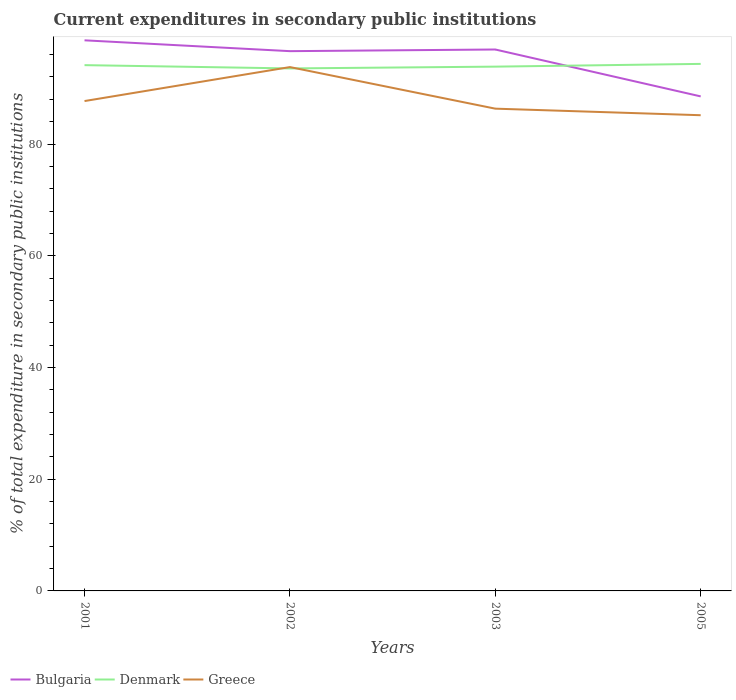How many different coloured lines are there?
Make the answer very short. 3. Is the number of lines equal to the number of legend labels?
Offer a very short reply. Yes. Across all years, what is the maximum current expenditures in secondary public institutions in Greece?
Give a very brief answer. 85.16. In which year was the current expenditures in secondary public institutions in Greece maximum?
Make the answer very short. 2005. What is the total current expenditures in secondary public institutions in Denmark in the graph?
Keep it short and to the point. -0.22. What is the difference between the highest and the second highest current expenditures in secondary public institutions in Greece?
Offer a very short reply. 8.62. How many years are there in the graph?
Keep it short and to the point. 4. What is the difference between two consecutive major ticks on the Y-axis?
Give a very brief answer. 20. What is the title of the graph?
Give a very brief answer. Current expenditures in secondary public institutions. Does "Micronesia" appear as one of the legend labels in the graph?
Your answer should be very brief. No. What is the label or title of the X-axis?
Ensure brevity in your answer.  Years. What is the label or title of the Y-axis?
Provide a short and direct response. % of total expenditure in secondary public institutions. What is the % of total expenditure in secondary public institutions of Bulgaria in 2001?
Provide a succinct answer. 98.57. What is the % of total expenditure in secondary public institutions of Denmark in 2001?
Give a very brief answer. 94.12. What is the % of total expenditure in secondary public institutions in Greece in 2001?
Your answer should be compact. 87.69. What is the % of total expenditure in secondary public institutions in Bulgaria in 2002?
Ensure brevity in your answer.  96.63. What is the % of total expenditure in secondary public institutions in Denmark in 2002?
Give a very brief answer. 93.53. What is the % of total expenditure in secondary public institutions of Greece in 2002?
Keep it short and to the point. 93.77. What is the % of total expenditure in secondary public institutions in Bulgaria in 2003?
Provide a succinct answer. 96.92. What is the % of total expenditure in secondary public institutions in Denmark in 2003?
Your response must be concise. 93.85. What is the % of total expenditure in secondary public institutions in Greece in 2003?
Ensure brevity in your answer.  86.33. What is the % of total expenditure in secondary public institutions of Bulgaria in 2005?
Make the answer very short. 88.53. What is the % of total expenditure in secondary public institutions of Denmark in 2005?
Ensure brevity in your answer.  94.35. What is the % of total expenditure in secondary public institutions in Greece in 2005?
Ensure brevity in your answer.  85.16. Across all years, what is the maximum % of total expenditure in secondary public institutions in Bulgaria?
Offer a very short reply. 98.57. Across all years, what is the maximum % of total expenditure in secondary public institutions in Denmark?
Keep it short and to the point. 94.35. Across all years, what is the maximum % of total expenditure in secondary public institutions in Greece?
Your answer should be compact. 93.77. Across all years, what is the minimum % of total expenditure in secondary public institutions of Bulgaria?
Ensure brevity in your answer.  88.53. Across all years, what is the minimum % of total expenditure in secondary public institutions of Denmark?
Your answer should be compact. 93.53. Across all years, what is the minimum % of total expenditure in secondary public institutions of Greece?
Your response must be concise. 85.16. What is the total % of total expenditure in secondary public institutions of Bulgaria in the graph?
Offer a terse response. 380.64. What is the total % of total expenditure in secondary public institutions of Denmark in the graph?
Your response must be concise. 375.86. What is the total % of total expenditure in secondary public institutions of Greece in the graph?
Your response must be concise. 352.96. What is the difference between the % of total expenditure in secondary public institutions in Bulgaria in 2001 and that in 2002?
Make the answer very short. 1.94. What is the difference between the % of total expenditure in secondary public institutions of Denmark in 2001 and that in 2002?
Give a very brief answer. 0.59. What is the difference between the % of total expenditure in secondary public institutions of Greece in 2001 and that in 2002?
Provide a short and direct response. -6.08. What is the difference between the % of total expenditure in secondary public institutions in Bulgaria in 2001 and that in 2003?
Ensure brevity in your answer.  1.64. What is the difference between the % of total expenditure in secondary public institutions in Denmark in 2001 and that in 2003?
Give a very brief answer. 0.27. What is the difference between the % of total expenditure in secondary public institutions of Greece in 2001 and that in 2003?
Your answer should be compact. 1.36. What is the difference between the % of total expenditure in secondary public institutions of Bulgaria in 2001 and that in 2005?
Your answer should be very brief. 10.04. What is the difference between the % of total expenditure in secondary public institutions of Denmark in 2001 and that in 2005?
Your answer should be very brief. -0.22. What is the difference between the % of total expenditure in secondary public institutions in Greece in 2001 and that in 2005?
Ensure brevity in your answer.  2.54. What is the difference between the % of total expenditure in secondary public institutions in Bulgaria in 2002 and that in 2003?
Your answer should be compact. -0.3. What is the difference between the % of total expenditure in secondary public institutions of Denmark in 2002 and that in 2003?
Your answer should be compact. -0.32. What is the difference between the % of total expenditure in secondary public institutions of Greece in 2002 and that in 2003?
Your answer should be compact. 7.44. What is the difference between the % of total expenditure in secondary public institutions in Bulgaria in 2002 and that in 2005?
Make the answer very short. 8.1. What is the difference between the % of total expenditure in secondary public institutions in Denmark in 2002 and that in 2005?
Provide a succinct answer. -0.81. What is the difference between the % of total expenditure in secondary public institutions of Greece in 2002 and that in 2005?
Provide a succinct answer. 8.62. What is the difference between the % of total expenditure in secondary public institutions in Bulgaria in 2003 and that in 2005?
Provide a succinct answer. 8.39. What is the difference between the % of total expenditure in secondary public institutions in Denmark in 2003 and that in 2005?
Your answer should be very brief. -0.49. What is the difference between the % of total expenditure in secondary public institutions of Greece in 2003 and that in 2005?
Ensure brevity in your answer.  1.18. What is the difference between the % of total expenditure in secondary public institutions of Bulgaria in 2001 and the % of total expenditure in secondary public institutions of Denmark in 2002?
Give a very brief answer. 5.03. What is the difference between the % of total expenditure in secondary public institutions in Bulgaria in 2001 and the % of total expenditure in secondary public institutions in Greece in 2002?
Give a very brief answer. 4.79. What is the difference between the % of total expenditure in secondary public institutions in Denmark in 2001 and the % of total expenditure in secondary public institutions in Greece in 2002?
Offer a very short reply. 0.35. What is the difference between the % of total expenditure in secondary public institutions in Bulgaria in 2001 and the % of total expenditure in secondary public institutions in Denmark in 2003?
Provide a short and direct response. 4.71. What is the difference between the % of total expenditure in secondary public institutions in Bulgaria in 2001 and the % of total expenditure in secondary public institutions in Greece in 2003?
Offer a very short reply. 12.23. What is the difference between the % of total expenditure in secondary public institutions in Denmark in 2001 and the % of total expenditure in secondary public institutions in Greece in 2003?
Provide a succinct answer. 7.79. What is the difference between the % of total expenditure in secondary public institutions in Bulgaria in 2001 and the % of total expenditure in secondary public institutions in Denmark in 2005?
Keep it short and to the point. 4.22. What is the difference between the % of total expenditure in secondary public institutions in Bulgaria in 2001 and the % of total expenditure in secondary public institutions in Greece in 2005?
Keep it short and to the point. 13.41. What is the difference between the % of total expenditure in secondary public institutions of Denmark in 2001 and the % of total expenditure in secondary public institutions of Greece in 2005?
Your answer should be compact. 8.97. What is the difference between the % of total expenditure in secondary public institutions in Bulgaria in 2002 and the % of total expenditure in secondary public institutions in Denmark in 2003?
Your answer should be very brief. 2.77. What is the difference between the % of total expenditure in secondary public institutions in Bulgaria in 2002 and the % of total expenditure in secondary public institutions in Greece in 2003?
Offer a terse response. 10.29. What is the difference between the % of total expenditure in secondary public institutions of Denmark in 2002 and the % of total expenditure in secondary public institutions of Greece in 2003?
Your response must be concise. 7.2. What is the difference between the % of total expenditure in secondary public institutions in Bulgaria in 2002 and the % of total expenditure in secondary public institutions in Denmark in 2005?
Provide a succinct answer. 2.28. What is the difference between the % of total expenditure in secondary public institutions in Bulgaria in 2002 and the % of total expenditure in secondary public institutions in Greece in 2005?
Give a very brief answer. 11.47. What is the difference between the % of total expenditure in secondary public institutions in Denmark in 2002 and the % of total expenditure in secondary public institutions in Greece in 2005?
Your answer should be compact. 8.38. What is the difference between the % of total expenditure in secondary public institutions in Bulgaria in 2003 and the % of total expenditure in secondary public institutions in Denmark in 2005?
Provide a short and direct response. 2.57. What is the difference between the % of total expenditure in secondary public institutions in Bulgaria in 2003 and the % of total expenditure in secondary public institutions in Greece in 2005?
Provide a succinct answer. 11.76. What is the difference between the % of total expenditure in secondary public institutions of Denmark in 2003 and the % of total expenditure in secondary public institutions of Greece in 2005?
Your answer should be compact. 8.7. What is the average % of total expenditure in secondary public institutions in Bulgaria per year?
Your answer should be compact. 95.16. What is the average % of total expenditure in secondary public institutions in Denmark per year?
Your response must be concise. 93.96. What is the average % of total expenditure in secondary public institutions in Greece per year?
Your answer should be very brief. 88.24. In the year 2001, what is the difference between the % of total expenditure in secondary public institutions of Bulgaria and % of total expenditure in secondary public institutions of Denmark?
Offer a terse response. 4.44. In the year 2001, what is the difference between the % of total expenditure in secondary public institutions in Bulgaria and % of total expenditure in secondary public institutions in Greece?
Your answer should be compact. 10.87. In the year 2001, what is the difference between the % of total expenditure in secondary public institutions in Denmark and % of total expenditure in secondary public institutions in Greece?
Your response must be concise. 6.43. In the year 2002, what is the difference between the % of total expenditure in secondary public institutions in Bulgaria and % of total expenditure in secondary public institutions in Denmark?
Offer a very short reply. 3.09. In the year 2002, what is the difference between the % of total expenditure in secondary public institutions of Bulgaria and % of total expenditure in secondary public institutions of Greece?
Keep it short and to the point. 2.85. In the year 2002, what is the difference between the % of total expenditure in secondary public institutions in Denmark and % of total expenditure in secondary public institutions in Greece?
Your answer should be compact. -0.24. In the year 2003, what is the difference between the % of total expenditure in secondary public institutions of Bulgaria and % of total expenditure in secondary public institutions of Denmark?
Keep it short and to the point. 3.07. In the year 2003, what is the difference between the % of total expenditure in secondary public institutions of Bulgaria and % of total expenditure in secondary public institutions of Greece?
Offer a terse response. 10.59. In the year 2003, what is the difference between the % of total expenditure in secondary public institutions of Denmark and % of total expenditure in secondary public institutions of Greece?
Ensure brevity in your answer.  7.52. In the year 2005, what is the difference between the % of total expenditure in secondary public institutions of Bulgaria and % of total expenditure in secondary public institutions of Denmark?
Make the answer very short. -5.82. In the year 2005, what is the difference between the % of total expenditure in secondary public institutions of Bulgaria and % of total expenditure in secondary public institutions of Greece?
Your answer should be compact. 3.37. In the year 2005, what is the difference between the % of total expenditure in secondary public institutions in Denmark and % of total expenditure in secondary public institutions in Greece?
Offer a terse response. 9.19. What is the ratio of the % of total expenditure in secondary public institutions in Bulgaria in 2001 to that in 2002?
Make the answer very short. 1.02. What is the ratio of the % of total expenditure in secondary public institutions in Greece in 2001 to that in 2002?
Give a very brief answer. 0.94. What is the ratio of the % of total expenditure in secondary public institutions in Greece in 2001 to that in 2003?
Your answer should be very brief. 1.02. What is the ratio of the % of total expenditure in secondary public institutions in Bulgaria in 2001 to that in 2005?
Your response must be concise. 1.11. What is the ratio of the % of total expenditure in secondary public institutions of Greece in 2001 to that in 2005?
Your answer should be compact. 1.03. What is the ratio of the % of total expenditure in secondary public institutions in Bulgaria in 2002 to that in 2003?
Make the answer very short. 1. What is the ratio of the % of total expenditure in secondary public institutions of Greece in 2002 to that in 2003?
Give a very brief answer. 1.09. What is the ratio of the % of total expenditure in secondary public institutions of Bulgaria in 2002 to that in 2005?
Offer a terse response. 1.09. What is the ratio of the % of total expenditure in secondary public institutions in Greece in 2002 to that in 2005?
Keep it short and to the point. 1.1. What is the ratio of the % of total expenditure in secondary public institutions of Bulgaria in 2003 to that in 2005?
Ensure brevity in your answer.  1.09. What is the ratio of the % of total expenditure in secondary public institutions in Denmark in 2003 to that in 2005?
Keep it short and to the point. 0.99. What is the ratio of the % of total expenditure in secondary public institutions of Greece in 2003 to that in 2005?
Ensure brevity in your answer.  1.01. What is the difference between the highest and the second highest % of total expenditure in secondary public institutions of Bulgaria?
Offer a terse response. 1.64. What is the difference between the highest and the second highest % of total expenditure in secondary public institutions of Denmark?
Give a very brief answer. 0.22. What is the difference between the highest and the second highest % of total expenditure in secondary public institutions of Greece?
Ensure brevity in your answer.  6.08. What is the difference between the highest and the lowest % of total expenditure in secondary public institutions in Bulgaria?
Keep it short and to the point. 10.04. What is the difference between the highest and the lowest % of total expenditure in secondary public institutions of Denmark?
Your response must be concise. 0.81. What is the difference between the highest and the lowest % of total expenditure in secondary public institutions in Greece?
Keep it short and to the point. 8.62. 